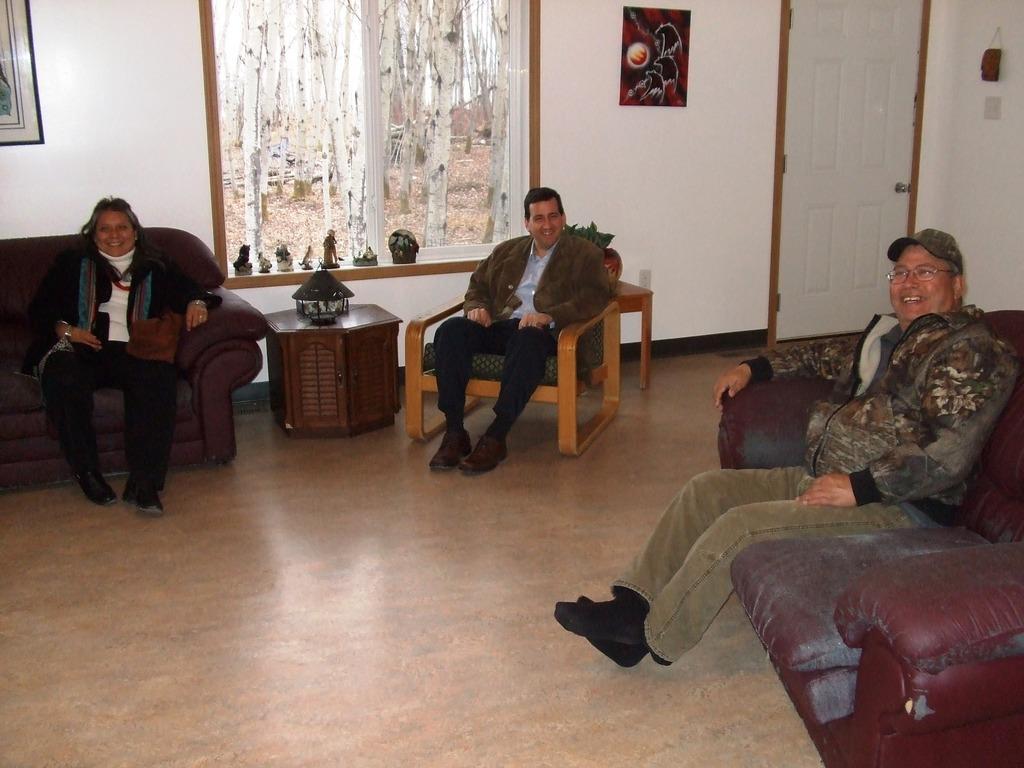Can you describe this image briefly? In this picture there are two men and a woman sitting on a sofa. There is a lamp on the table. Few show pieces are on the wall. Some frames are visible on the wall. There is a door to the right side. 